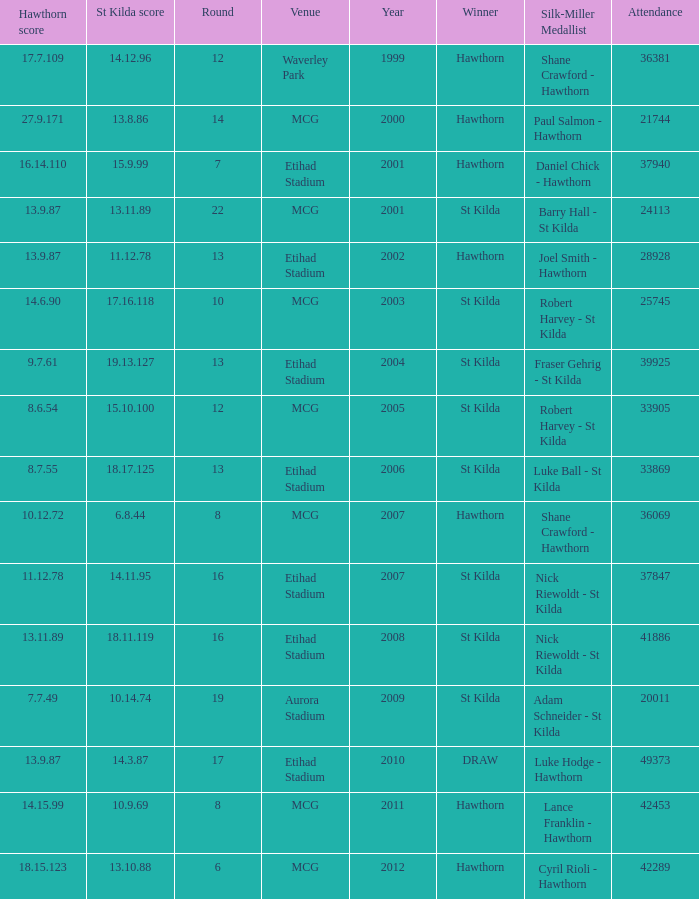Would you mind parsing the complete table? {'header': ['Hawthorn score', 'St Kilda score', 'Round', 'Venue', 'Year', 'Winner', 'Silk-Miller Medallist', 'Attendance'], 'rows': [['17.7.109', '14.12.96', '12', 'Waverley Park', '1999', 'Hawthorn', 'Shane Crawford - Hawthorn', '36381'], ['27.9.171', '13.8.86', '14', 'MCG', '2000', 'Hawthorn', 'Paul Salmon - Hawthorn', '21744'], ['16.14.110', '15.9.99', '7', 'Etihad Stadium', '2001', 'Hawthorn', 'Daniel Chick - Hawthorn', '37940'], ['13.9.87', '13.11.89', '22', 'MCG', '2001', 'St Kilda', 'Barry Hall - St Kilda', '24113'], ['13.9.87', '11.12.78', '13', 'Etihad Stadium', '2002', 'Hawthorn', 'Joel Smith - Hawthorn', '28928'], ['14.6.90', '17.16.118', '10', 'MCG', '2003', 'St Kilda', 'Robert Harvey - St Kilda', '25745'], ['9.7.61', '19.13.127', '13', 'Etihad Stadium', '2004', 'St Kilda', 'Fraser Gehrig - St Kilda', '39925'], ['8.6.54', '15.10.100', '12', 'MCG', '2005', 'St Kilda', 'Robert Harvey - St Kilda', '33905'], ['8.7.55', '18.17.125', '13', 'Etihad Stadium', '2006', 'St Kilda', 'Luke Ball - St Kilda', '33869'], ['10.12.72', '6.8.44', '8', 'MCG', '2007', 'Hawthorn', 'Shane Crawford - Hawthorn', '36069'], ['11.12.78', '14.11.95', '16', 'Etihad Stadium', '2007', 'St Kilda', 'Nick Riewoldt - St Kilda', '37847'], ['13.11.89', '18.11.119', '16', 'Etihad Stadium', '2008', 'St Kilda', 'Nick Riewoldt - St Kilda', '41886'], ['7.7.49', '10.14.74', '19', 'Aurora Stadium', '2009', 'St Kilda', 'Adam Schneider - St Kilda', '20011'], ['13.9.87', '14.3.87', '17', 'Etihad Stadium', '2010', 'DRAW', 'Luke Hodge - Hawthorn', '49373'], ['14.15.99', '10.9.69', '8', 'MCG', '2011', 'Hawthorn', 'Lance Franklin - Hawthorn', '42453'], ['18.15.123', '13.10.88', '6', 'MCG', '2012', 'Hawthorn', 'Cyril Rioli - Hawthorn', '42289']]} What is the hawthorn score at the year 2000? 279171.0. 